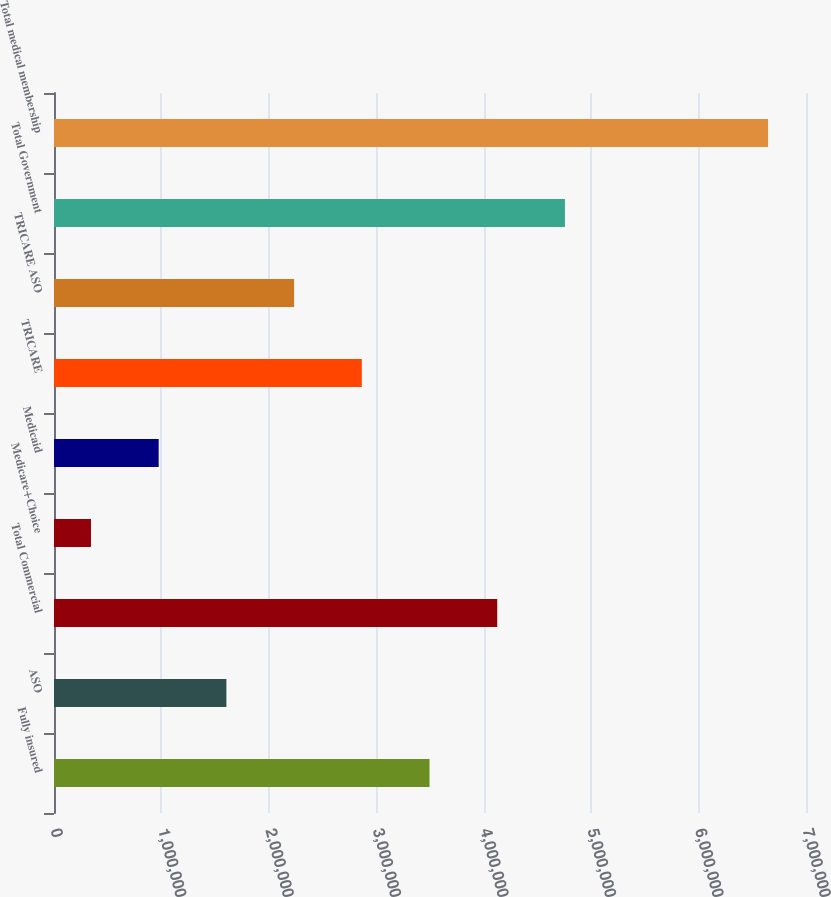Convert chart to OTSL. <chart><loc_0><loc_0><loc_500><loc_500><bar_chart><fcel>Fully insured<fcel>ASO<fcel>Total Commercial<fcel>Medicare+Choice<fcel>Medicaid<fcel>TRICARE<fcel>TRICARE ASO<fcel>Total Government<fcel>Total medical membership<nl><fcel>3.4956e+06<fcel>1.6047e+06<fcel>4.1259e+06<fcel>344100<fcel>974400<fcel>2.8653e+06<fcel>2.235e+06<fcel>4.7562e+06<fcel>6.6471e+06<nl></chart> 